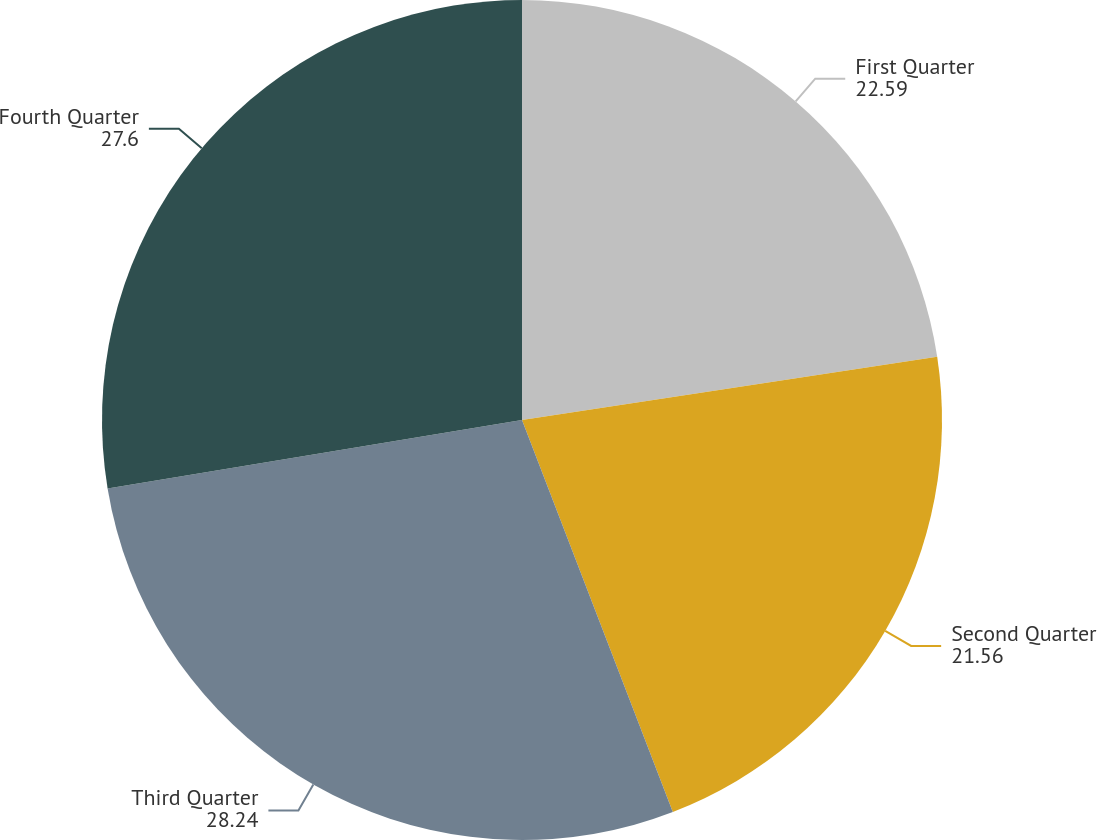Convert chart. <chart><loc_0><loc_0><loc_500><loc_500><pie_chart><fcel>First Quarter<fcel>Second Quarter<fcel>Third Quarter<fcel>Fourth Quarter<nl><fcel>22.59%<fcel>21.56%<fcel>28.24%<fcel>27.6%<nl></chart> 